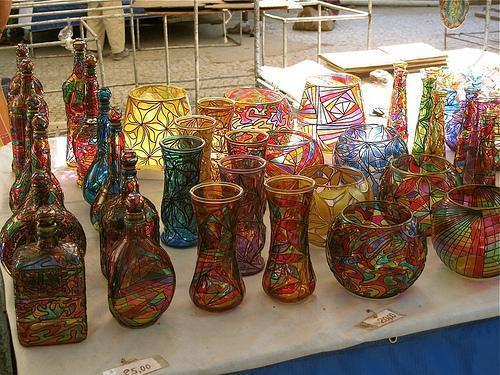How many tables hold the vases?
Give a very brief answer. 1. 